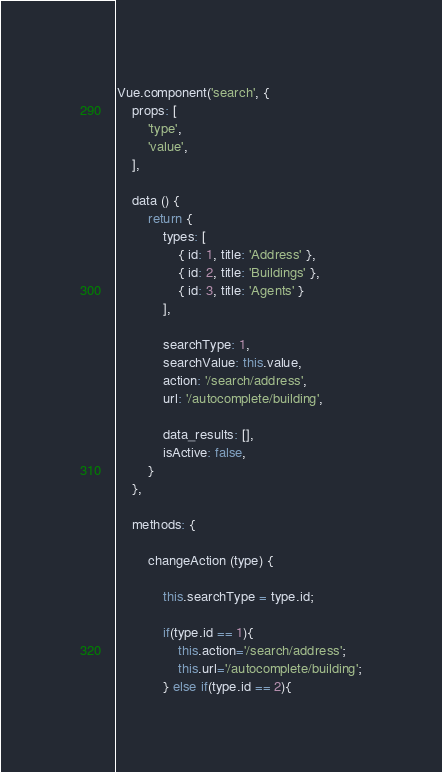Convert code to text. <code><loc_0><loc_0><loc_500><loc_500><_JavaScript_>Vue.component('search', {
    props: [
        'type',
        'value',
    ],

    data () {
        return {
            types: [
                { id: 1, title: 'Address' },
                { id: 2, title: 'Buildings' },
                { id: 3, title: 'Agents' }
            ],

            searchType: 1,
            searchValue: this.value,
            action: '/search/address',
            url: '/autocomplete/building',

            data_results: [],
            isActive: false,
        }
    },

    methods: {

        changeAction (type) {

            this.searchType = type.id;

            if(type.id == 1){
                this.action='/search/address';
                this.url='/autocomplete/building';
            } else if(type.id == 2){</code> 